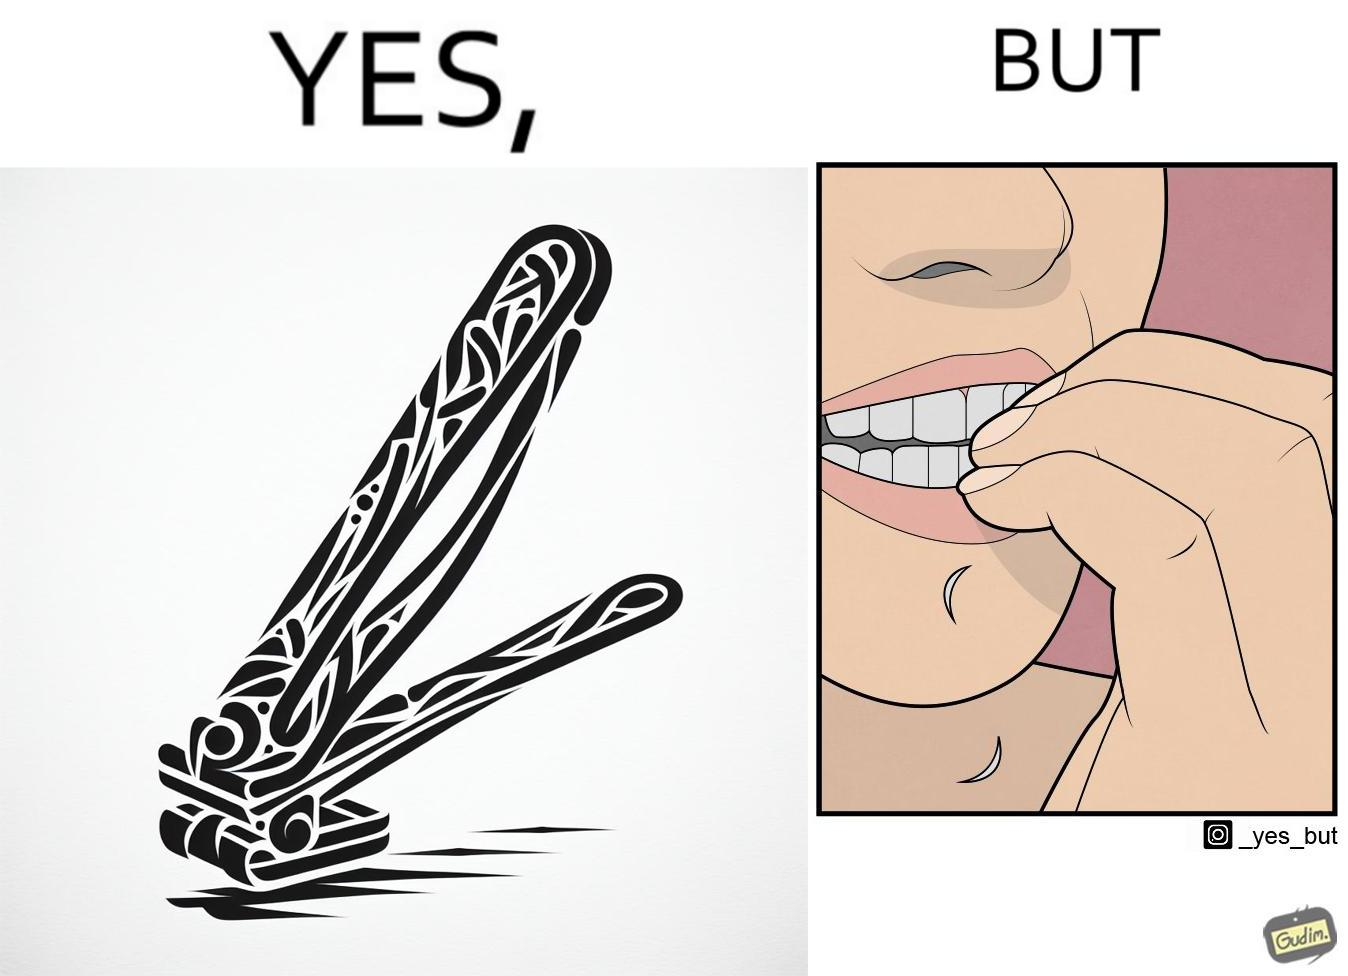Is this a satirical image? Yes, this image is satirical. 